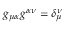<formula> <loc_0><loc_0><loc_500><loc_500>g _ { \mu \alpha } g ^ { \alpha \nu } = \delta _ { \mu } ^ { \nu }</formula> 